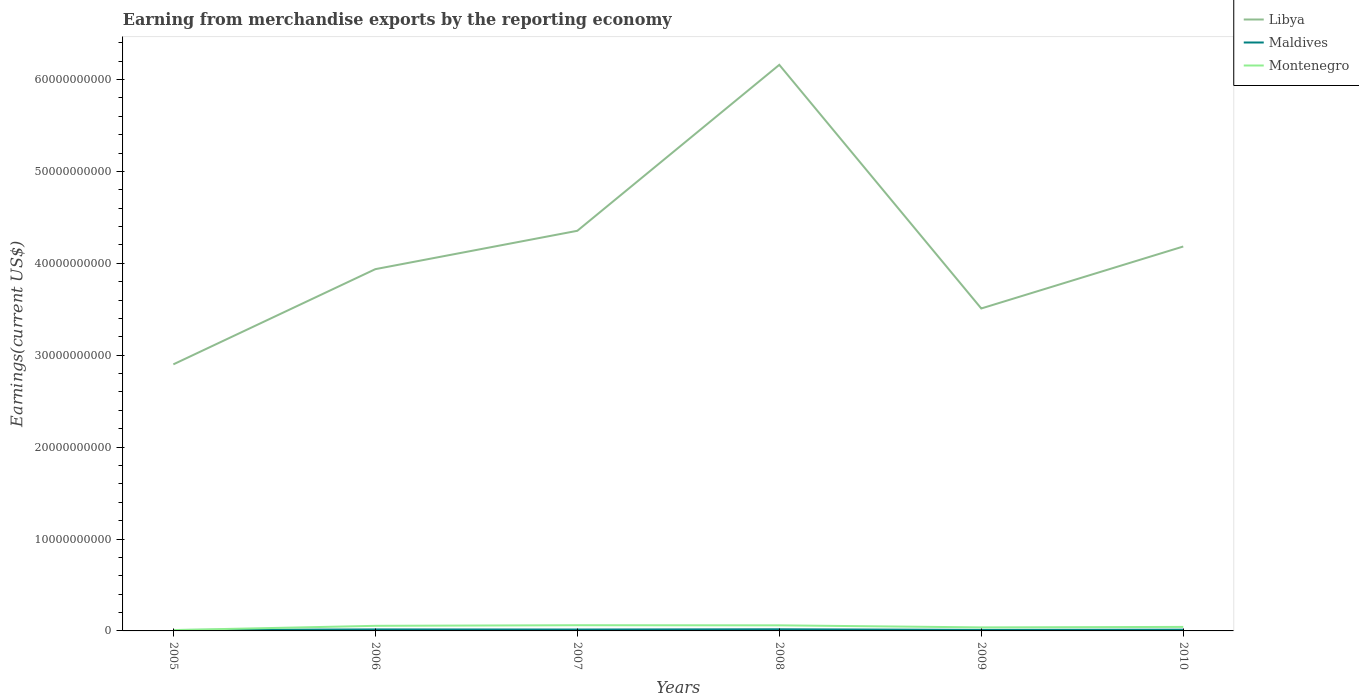Does the line corresponding to Maldives intersect with the line corresponding to Montenegro?
Your answer should be compact. Yes. Is the number of lines equal to the number of legend labels?
Provide a short and direct response. Yes. Across all years, what is the maximum amount earned from merchandise exports in Libya?
Make the answer very short. 2.90e+1. What is the total amount earned from merchandise exports in Montenegro in the graph?
Provide a short and direct response. 2.36e+08. What is the difference between the highest and the second highest amount earned from merchandise exports in Libya?
Your answer should be very brief. 3.26e+1. What is the difference between the highest and the lowest amount earned from merchandise exports in Maldives?
Keep it short and to the point. 3. How many lines are there?
Give a very brief answer. 3. Does the graph contain grids?
Offer a very short reply. No. What is the title of the graph?
Keep it short and to the point. Earning from merchandise exports by the reporting economy. What is the label or title of the X-axis?
Your response must be concise. Years. What is the label or title of the Y-axis?
Offer a terse response. Earnings(current US$). What is the Earnings(current US$) of Libya in 2005?
Your answer should be very brief. 2.90e+1. What is the Earnings(current US$) of Maldives in 2005?
Offer a terse response. 9.87e+07. What is the Earnings(current US$) of Montenegro in 2005?
Your answer should be very brief. 9.18e+07. What is the Earnings(current US$) in Libya in 2006?
Your response must be concise. 3.94e+1. What is the Earnings(current US$) in Maldives in 2006?
Your answer should be very brief. 1.63e+08. What is the Earnings(current US$) of Montenegro in 2006?
Ensure brevity in your answer.  5.53e+08. What is the Earnings(current US$) of Libya in 2007?
Give a very brief answer. 4.35e+1. What is the Earnings(current US$) in Maldives in 2007?
Provide a succinct answer. 1.51e+08. What is the Earnings(current US$) of Montenegro in 2007?
Keep it short and to the point. 6.20e+08. What is the Earnings(current US$) in Libya in 2008?
Keep it short and to the point. 6.16e+1. What is the Earnings(current US$) in Maldives in 2008?
Your answer should be very brief. 1.79e+08. What is the Earnings(current US$) of Montenegro in 2008?
Ensure brevity in your answer.  6.07e+08. What is the Earnings(current US$) of Libya in 2009?
Your answer should be very brief. 3.51e+1. What is the Earnings(current US$) of Maldives in 2009?
Keep it short and to the point. 1.14e+08. What is the Earnings(current US$) in Montenegro in 2009?
Give a very brief answer. 3.84e+08. What is the Earnings(current US$) of Libya in 2010?
Offer a terse response. 4.18e+1. What is the Earnings(current US$) of Maldives in 2010?
Your answer should be very brief. 1.35e+08. What is the Earnings(current US$) in Montenegro in 2010?
Give a very brief answer. 4.37e+08. Across all years, what is the maximum Earnings(current US$) of Libya?
Ensure brevity in your answer.  6.16e+1. Across all years, what is the maximum Earnings(current US$) in Maldives?
Offer a terse response. 1.79e+08. Across all years, what is the maximum Earnings(current US$) in Montenegro?
Your answer should be very brief. 6.20e+08. Across all years, what is the minimum Earnings(current US$) of Libya?
Make the answer very short. 2.90e+1. Across all years, what is the minimum Earnings(current US$) of Maldives?
Give a very brief answer. 9.87e+07. Across all years, what is the minimum Earnings(current US$) of Montenegro?
Ensure brevity in your answer.  9.18e+07. What is the total Earnings(current US$) in Libya in the graph?
Keep it short and to the point. 2.50e+11. What is the total Earnings(current US$) of Maldives in the graph?
Keep it short and to the point. 8.41e+08. What is the total Earnings(current US$) in Montenegro in the graph?
Ensure brevity in your answer.  2.69e+09. What is the difference between the Earnings(current US$) of Libya in 2005 and that in 2006?
Provide a succinct answer. -1.04e+1. What is the difference between the Earnings(current US$) of Maldives in 2005 and that in 2006?
Offer a terse response. -6.41e+07. What is the difference between the Earnings(current US$) of Montenegro in 2005 and that in 2006?
Give a very brief answer. -4.62e+08. What is the difference between the Earnings(current US$) in Libya in 2005 and that in 2007?
Offer a very short reply. -1.45e+1. What is the difference between the Earnings(current US$) of Maldives in 2005 and that in 2007?
Provide a succinct answer. -5.27e+07. What is the difference between the Earnings(current US$) in Montenegro in 2005 and that in 2007?
Your response must be concise. -5.29e+08. What is the difference between the Earnings(current US$) of Libya in 2005 and that in 2008?
Offer a terse response. -3.26e+1. What is the difference between the Earnings(current US$) of Maldives in 2005 and that in 2008?
Offer a terse response. -8.04e+07. What is the difference between the Earnings(current US$) of Montenegro in 2005 and that in 2008?
Ensure brevity in your answer.  -5.15e+08. What is the difference between the Earnings(current US$) of Libya in 2005 and that in 2009?
Offer a very short reply. -6.08e+09. What is the difference between the Earnings(current US$) of Maldives in 2005 and that in 2009?
Provide a short and direct response. -1.51e+07. What is the difference between the Earnings(current US$) in Montenegro in 2005 and that in 2009?
Your answer should be very brief. -2.92e+08. What is the difference between the Earnings(current US$) in Libya in 2005 and that in 2010?
Your response must be concise. -1.28e+1. What is the difference between the Earnings(current US$) of Maldives in 2005 and that in 2010?
Give a very brief answer. -3.67e+07. What is the difference between the Earnings(current US$) of Montenegro in 2005 and that in 2010?
Your answer should be compact. -3.45e+08. What is the difference between the Earnings(current US$) in Libya in 2006 and that in 2007?
Give a very brief answer. -4.17e+09. What is the difference between the Earnings(current US$) of Maldives in 2006 and that in 2007?
Make the answer very short. 1.15e+07. What is the difference between the Earnings(current US$) in Montenegro in 2006 and that in 2007?
Offer a very short reply. -6.70e+07. What is the difference between the Earnings(current US$) in Libya in 2006 and that in 2008?
Your answer should be very brief. -2.22e+1. What is the difference between the Earnings(current US$) in Maldives in 2006 and that in 2008?
Your response must be concise. -1.63e+07. What is the difference between the Earnings(current US$) in Montenegro in 2006 and that in 2008?
Provide a succinct answer. -5.36e+07. What is the difference between the Earnings(current US$) of Libya in 2006 and that in 2009?
Your answer should be very brief. 4.28e+09. What is the difference between the Earnings(current US$) in Maldives in 2006 and that in 2009?
Make the answer very short. 4.90e+07. What is the difference between the Earnings(current US$) of Montenegro in 2006 and that in 2009?
Offer a terse response. 1.69e+08. What is the difference between the Earnings(current US$) in Libya in 2006 and that in 2010?
Your response must be concise. -2.46e+09. What is the difference between the Earnings(current US$) of Maldives in 2006 and that in 2010?
Your response must be concise. 2.75e+07. What is the difference between the Earnings(current US$) in Montenegro in 2006 and that in 2010?
Ensure brevity in your answer.  1.17e+08. What is the difference between the Earnings(current US$) of Libya in 2007 and that in 2008?
Offer a very short reply. -1.81e+1. What is the difference between the Earnings(current US$) in Maldives in 2007 and that in 2008?
Offer a very short reply. -2.77e+07. What is the difference between the Earnings(current US$) in Montenegro in 2007 and that in 2008?
Offer a terse response. 1.34e+07. What is the difference between the Earnings(current US$) of Libya in 2007 and that in 2009?
Offer a terse response. 8.45e+09. What is the difference between the Earnings(current US$) of Maldives in 2007 and that in 2009?
Provide a succinct answer. 3.75e+07. What is the difference between the Earnings(current US$) in Montenegro in 2007 and that in 2009?
Your answer should be very brief. 2.36e+08. What is the difference between the Earnings(current US$) in Libya in 2007 and that in 2010?
Make the answer very short. 1.71e+09. What is the difference between the Earnings(current US$) in Maldives in 2007 and that in 2010?
Make the answer very short. 1.60e+07. What is the difference between the Earnings(current US$) of Montenegro in 2007 and that in 2010?
Provide a succinct answer. 1.84e+08. What is the difference between the Earnings(current US$) of Libya in 2008 and that in 2009?
Give a very brief answer. 2.65e+1. What is the difference between the Earnings(current US$) in Maldives in 2008 and that in 2009?
Your answer should be very brief. 6.53e+07. What is the difference between the Earnings(current US$) in Montenegro in 2008 and that in 2009?
Your answer should be very brief. 2.23e+08. What is the difference between the Earnings(current US$) in Libya in 2008 and that in 2010?
Your response must be concise. 1.98e+1. What is the difference between the Earnings(current US$) in Maldives in 2008 and that in 2010?
Provide a succinct answer. 4.37e+07. What is the difference between the Earnings(current US$) in Montenegro in 2008 and that in 2010?
Keep it short and to the point. 1.70e+08. What is the difference between the Earnings(current US$) of Libya in 2009 and that in 2010?
Your response must be concise. -6.74e+09. What is the difference between the Earnings(current US$) of Maldives in 2009 and that in 2010?
Provide a succinct answer. -2.15e+07. What is the difference between the Earnings(current US$) in Montenegro in 2009 and that in 2010?
Your response must be concise. -5.27e+07. What is the difference between the Earnings(current US$) in Libya in 2005 and the Earnings(current US$) in Maldives in 2006?
Make the answer very short. 2.88e+1. What is the difference between the Earnings(current US$) in Libya in 2005 and the Earnings(current US$) in Montenegro in 2006?
Provide a short and direct response. 2.85e+1. What is the difference between the Earnings(current US$) of Maldives in 2005 and the Earnings(current US$) of Montenegro in 2006?
Offer a terse response. -4.55e+08. What is the difference between the Earnings(current US$) of Libya in 2005 and the Earnings(current US$) of Maldives in 2007?
Your answer should be compact. 2.89e+1. What is the difference between the Earnings(current US$) in Libya in 2005 and the Earnings(current US$) in Montenegro in 2007?
Your response must be concise. 2.84e+1. What is the difference between the Earnings(current US$) in Maldives in 2005 and the Earnings(current US$) in Montenegro in 2007?
Ensure brevity in your answer.  -5.22e+08. What is the difference between the Earnings(current US$) of Libya in 2005 and the Earnings(current US$) of Maldives in 2008?
Keep it short and to the point. 2.88e+1. What is the difference between the Earnings(current US$) of Libya in 2005 and the Earnings(current US$) of Montenegro in 2008?
Ensure brevity in your answer.  2.84e+1. What is the difference between the Earnings(current US$) of Maldives in 2005 and the Earnings(current US$) of Montenegro in 2008?
Your answer should be very brief. -5.08e+08. What is the difference between the Earnings(current US$) in Libya in 2005 and the Earnings(current US$) in Maldives in 2009?
Give a very brief answer. 2.89e+1. What is the difference between the Earnings(current US$) of Libya in 2005 and the Earnings(current US$) of Montenegro in 2009?
Provide a succinct answer. 2.86e+1. What is the difference between the Earnings(current US$) of Maldives in 2005 and the Earnings(current US$) of Montenegro in 2009?
Make the answer very short. -2.85e+08. What is the difference between the Earnings(current US$) of Libya in 2005 and the Earnings(current US$) of Maldives in 2010?
Your response must be concise. 2.89e+1. What is the difference between the Earnings(current US$) in Libya in 2005 and the Earnings(current US$) in Montenegro in 2010?
Offer a very short reply. 2.86e+1. What is the difference between the Earnings(current US$) in Maldives in 2005 and the Earnings(current US$) in Montenegro in 2010?
Provide a short and direct response. -3.38e+08. What is the difference between the Earnings(current US$) in Libya in 2006 and the Earnings(current US$) in Maldives in 2007?
Your response must be concise. 3.92e+1. What is the difference between the Earnings(current US$) in Libya in 2006 and the Earnings(current US$) in Montenegro in 2007?
Your answer should be very brief. 3.87e+1. What is the difference between the Earnings(current US$) in Maldives in 2006 and the Earnings(current US$) in Montenegro in 2007?
Ensure brevity in your answer.  -4.58e+08. What is the difference between the Earnings(current US$) of Libya in 2006 and the Earnings(current US$) of Maldives in 2008?
Offer a terse response. 3.92e+1. What is the difference between the Earnings(current US$) in Libya in 2006 and the Earnings(current US$) in Montenegro in 2008?
Offer a very short reply. 3.88e+1. What is the difference between the Earnings(current US$) of Maldives in 2006 and the Earnings(current US$) of Montenegro in 2008?
Keep it short and to the point. -4.44e+08. What is the difference between the Earnings(current US$) in Libya in 2006 and the Earnings(current US$) in Maldives in 2009?
Keep it short and to the point. 3.92e+1. What is the difference between the Earnings(current US$) in Libya in 2006 and the Earnings(current US$) in Montenegro in 2009?
Offer a terse response. 3.90e+1. What is the difference between the Earnings(current US$) of Maldives in 2006 and the Earnings(current US$) of Montenegro in 2009?
Keep it short and to the point. -2.21e+08. What is the difference between the Earnings(current US$) of Libya in 2006 and the Earnings(current US$) of Maldives in 2010?
Provide a short and direct response. 3.92e+1. What is the difference between the Earnings(current US$) in Libya in 2006 and the Earnings(current US$) in Montenegro in 2010?
Your answer should be compact. 3.89e+1. What is the difference between the Earnings(current US$) of Maldives in 2006 and the Earnings(current US$) of Montenegro in 2010?
Offer a terse response. -2.74e+08. What is the difference between the Earnings(current US$) in Libya in 2007 and the Earnings(current US$) in Maldives in 2008?
Your answer should be very brief. 4.34e+1. What is the difference between the Earnings(current US$) in Libya in 2007 and the Earnings(current US$) in Montenegro in 2008?
Your answer should be very brief. 4.29e+1. What is the difference between the Earnings(current US$) of Maldives in 2007 and the Earnings(current US$) of Montenegro in 2008?
Provide a short and direct response. -4.56e+08. What is the difference between the Earnings(current US$) in Libya in 2007 and the Earnings(current US$) in Maldives in 2009?
Provide a succinct answer. 4.34e+1. What is the difference between the Earnings(current US$) in Libya in 2007 and the Earnings(current US$) in Montenegro in 2009?
Your answer should be compact. 4.32e+1. What is the difference between the Earnings(current US$) of Maldives in 2007 and the Earnings(current US$) of Montenegro in 2009?
Keep it short and to the point. -2.33e+08. What is the difference between the Earnings(current US$) in Libya in 2007 and the Earnings(current US$) in Maldives in 2010?
Your response must be concise. 4.34e+1. What is the difference between the Earnings(current US$) in Libya in 2007 and the Earnings(current US$) in Montenegro in 2010?
Provide a short and direct response. 4.31e+1. What is the difference between the Earnings(current US$) of Maldives in 2007 and the Earnings(current US$) of Montenegro in 2010?
Ensure brevity in your answer.  -2.85e+08. What is the difference between the Earnings(current US$) of Libya in 2008 and the Earnings(current US$) of Maldives in 2009?
Ensure brevity in your answer.  6.15e+1. What is the difference between the Earnings(current US$) in Libya in 2008 and the Earnings(current US$) in Montenegro in 2009?
Keep it short and to the point. 6.12e+1. What is the difference between the Earnings(current US$) of Maldives in 2008 and the Earnings(current US$) of Montenegro in 2009?
Provide a succinct answer. -2.05e+08. What is the difference between the Earnings(current US$) in Libya in 2008 and the Earnings(current US$) in Maldives in 2010?
Ensure brevity in your answer.  6.15e+1. What is the difference between the Earnings(current US$) in Libya in 2008 and the Earnings(current US$) in Montenegro in 2010?
Offer a terse response. 6.12e+1. What is the difference between the Earnings(current US$) in Maldives in 2008 and the Earnings(current US$) in Montenegro in 2010?
Your answer should be compact. -2.58e+08. What is the difference between the Earnings(current US$) of Libya in 2009 and the Earnings(current US$) of Maldives in 2010?
Provide a succinct answer. 3.50e+1. What is the difference between the Earnings(current US$) in Libya in 2009 and the Earnings(current US$) in Montenegro in 2010?
Offer a very short reply. 3.46e+1. What is the difference between the Earnings(current US$) of Maldives in 2009 and the Earnings(current US$) of Montenegro in 2010?
Ensure brevity in your answer.  -3.23e+08. What is the average Earnings(current US$) in Libya per year?
Provide a succinct answer. 4.17e+1. What is the average Earnings(current US$) of Maldives per year?
Give a very brief answer. 1.40e+08. What is the average Earnings(current US$) of Montenegro per year?
Make the answer very short. 4.49e+08. In the year 2005, what is the difference between the Earnings(current US$) in Libya and Earnings(current US$) in Maldives?
Offer a terse response. 2.89e+1. In the year 2005, what is the difference between the Earnings(current US$) in Libya and Earnings(current US$) in Montenegro?
Your answer should be compact. 2.89e+1. In the year 2005, what is the difference between the Earnings(current US$) in Maldives and Earnings(current US$) in Montenegro?
Your response must be concise. 6.92e+06. In the year 2006, what is the difference between the Earnings(current US$) of Libya and Earnings(current US$) of Maldives?
Ensure brevity in your answer.  3.92e+1. In the year 2006, what is the difference between the Earnings(current US$) of Libya and Earnings(current US$) of Montenegro?
Make the answer very short. 3.88e+1. In the year 2006, what is the difference between the Earnings(current US$) in Maldives and Earnings(current US$) in Montenegro?
Your answer should be very brief. -3.91e+08. In the year 2007, what is the difference between the Earnings(current US$) in Libya and Earnings(current US$) in Maldives?
Provide a short and direct response. 4.34e+1. In the year 2007, what is the difference between the Earnings(current US$) of Libya and Earnings(current US$) of Montenegro?
Make the answer very short. 4.29e+1. In the year 2007, what is the difference between the Earnings(current US$) in Maldives and Earnings(current US$) in Montenegro?
Your answer should be compact. -4.69e+08. In the year 2008, what is the difference between the Earnings(current US$) in Libya and Earnings(current US$) in Maldives?
Your answer should be compact. 6.14e+1. In the year 2008, what is the difference between the Earnings(current US$) in Libya and Earnings(current US$) in Montenegro?
Keep it short and to the point. 6.10e+1. In the year 2008, what is the difference between the Earnings(current US$) in Maldives and Earnings(current US$) in Montenegro?
Ensure brevity in your answer.  -4.28e+08. In the year 2009, what is the difference between the Earnings(current US$) of Libya and Earnings(current US$) of Maldives?
Offer a terse response. 3.50e+1. In the year 2009, what is the difference between the Earnings(current US$) in Libya and Earnings(current US$) in Montenegro?
Your answer should be compact. 3.47e+1. In the year 2009, what is the difference between the Earnings(current US$) in Maldives and Earnings(current US$) in Montenegro?
Keep it short and to the point. -2.70e+08. In the year 2010, what is the difference between the Earnings(current US$) in Libya and Earnings(current US$) in Maldives?
Your answer should be very brief. 4.17e+1. In the year 2010, what is the difference between the Earnings(current US$) of Libya and Earnings(current US$) of Montenegro?
Your answer should be very brief. 4.14e+1. In the year 2010, what is the difference between the Earnings(current US$) in Maldives and Earnings(current US$) in Montenegro?
Ensure brevity in your answer.  -3.01e+08. What is the ratio of the Earnings(current US$) of Libya in 2005 to that in 2006?
Offer a terse response. 0.74. What is the ratio of the Earnings(current US$) in Maldives in 2005 to that in 2006?
Provide a short and direct response. 0.61. What is the ratio of the Earnings(current US$) of Montenegro in 2005 to that in 2006?
Provide a short and direct response. 0.17. What is the ratio of the Earnings(current US$) of Libya in 2005 to that in 2007?
Keep it short and to the point. 0.67. What is the ratio of the Earnings(current US$) in Maldives in 2005 to that in 2007?
Keep it short and to the point. 0.65. What is the ratio of the Earnings(current US$) of Montenegro in 2005 to that in 2007?
Provide a short and direct response. 0.15. What is the ratio of the Earnings(current US$) of Libya in 2005 to that in 2008?
Your answer should be compact. 0.47. What is the ratio of the Earnings(current US$) in Maldives in 2005 to that in 2008?
Your answer should be very brief. 0.55. What is the ratio of the Earnings(current US$) of Montenegro in 2005 to that in 2008?
Ensure brevity in your answer.  0.15. What is the ratio of the Earnings(current US$) in Libya in 2005 to that in 2009?
Your answer should be very brief. 0.83. What is the ratio of the Earnings(current US$) of Maldives in 2005 to that in 2009?
Give a very brief answer. 0.87. What is the ratio of the Earnings(current US$) in Montenegro in 2005 to that in 2009?
Give a very brief answer. 0.24. What is the ratio of the Earnings(current US$) of Libya in 2005 to that in 2010?
Your answer should be very brief. 0.69. What is the ratio of the Earnings(current US$) of Maldives in 2005 to that in 2010?
Your answer should be compact. 0.73. What is the ratio of the Earnings(current US$) of Montenegro in 2005 to that in 2010?
Provide a short and direct response. 0.21. What is the ratio of the Earnings(current US$) in Libya in 2006 to that in 2007?
Make the answer very short. 0.9. What is the ratio of the Earnings(current US$) of Maldives in 2006 to that in 2007?
Your response must be concise. 1.08. What is the ratio of the Earnings(current US$) in Montenegro in 2006 to that in 2007?
Ensure brevity in your answer.  0.89. What is the ratio of the Earnings(current US$) in Libya in 2006 to that in 2008?
Ensure brevity in your answer.  0.64. What is the ratio of the Earnings(current US$) of Maldives in 2006 to that in 2008?
Give a very brief answer. 0.91. What is the ratio of the Earnings(current US$) of Montenegro in 2006 to that in 2008?
Your answer should be very brief. 0.91. What is the ratio of the Earnings(current US$) in Libya in 2006 to that in 2009?
Give a very brief answer. 1.12. What is the ratio of the Earnings(current US$) of Maldives in 2006 to that in 2009?
Your answer should be very brief. 1.43. What is the ratio of the Earnings(current US$) in Montenegro in 2006 to that in 2009?
Your response must be concise. 1.44. What is the ratio of the Earnings(current US$) in Libya in 2006 to that in 2010?
Your answer should be compact. 0.94. What is the ratio of the Earnings(current US$) in Maldives in 2006 to that in 2010?
Make the answer very short. 1.2. What is the ratio of the Earnings(current US$) in Montenegro in 2006 to that in 2010?
Your answer should be compact. 1.27. What is the ratio of the Earnings(current US$) of Libya in 2007 to that in 2008?
Ensure brevity in your answer.  0.71. What is the ratio of the Earnings(current US$) in Maldives in 2007 to that in 2008?
Your response must be concise. 0.85. What is the ratio of the Earnings(current US$) in Montenegro in 2007 to that in 2008?
Provide a short and direct response. 1.02. What is the ratio of the Earnings(current US$) of Libya in 2007 to that in 2009?
Your answer should be compact. 1.24. What is the ratio of the Earnings(current US$) of Maldives in 2007 to that in 2009?
Make the answer very short. 1.33. What is the ratio of the Earnings(current US$) of Montenegro in 2007 to that in 2009?
Provide a short and direct response. 1.62. What is the ratio of the Earnings(current US$) in Libya in 2007 to that in 2010?
Provide a succinct answer. 1.04. What is the ratio of the Earnings(current US$) in Maldives in 2007 to that in 2010?
Your answer should be compact. 1.12. What is the ratio of the Earnings(current US$) of Montenegro in 2007 to that in 2010?
Provide a succinct answer. 1.42. What is the ratio of the Earnings(current US$) of Libya in 2008 to that in 2009?
Keep it short and to the point. 1.76. What is the ratio of the Earnings(current US$) in Maldives in 2008 to that in 2009?
Provide a short and direct response. 1.57. What is the ratio of the Earnings(current US$) in Montenegro in 2008 to that in 2009?
Offer a very short reply. 1.58. What is the ratio of the Earnings(current US$) in Libya in 2008 to that in 2010?
Keep it short and to the point. 1.47. What is the ratio of the Earnings(current US$) in Maldives in 2008 to that in 2010?
Your answer should be compact. 1.32. What is the ratio of the Earnings(current US$) of Montenegro in 2008 to that in 2010?
Keep it short and to the point. 1.39. What is the ratio of the Earnings(current US$) in Libya in 2009 to that in 2010?
Give a very brief answer. 0.84. What is the ratio of the Earnings(current US$) of Maldives in 2009 to that in 2010?
Keep it short and to the point. 0.84. What is the ratio of the Earnings(current US$) of Montenegro in 2009 to that in 2010?
Provide a succinct answer. 0.88. What is the difference between the highest and the second highest Earnings(current US$) in Libya?
Keep it short and to the point. 1.81e+1. What is the difference between the highest and the second highest Earnings(current US$) of Maldives?
Keep it short and to the point. 1.63e+07. What is the difference between the highest and the second highest Earnings(current US$) of Montenegro?
Your answer should be compact. 1.34e+07. What is the difference between the highest and the lowest Earnings(current US$) in Libya?
Provide a short and direct response. 3.26e+1. What is the difference between the highest and the lowest Earnings(current US$) of Maldives?
Make the answer very short. 8.04e+07. What is the difference between the highest and the lowest Earnings(current US$) in Montenegro?
Ensure brevity in your answer.  5.29e+08. 